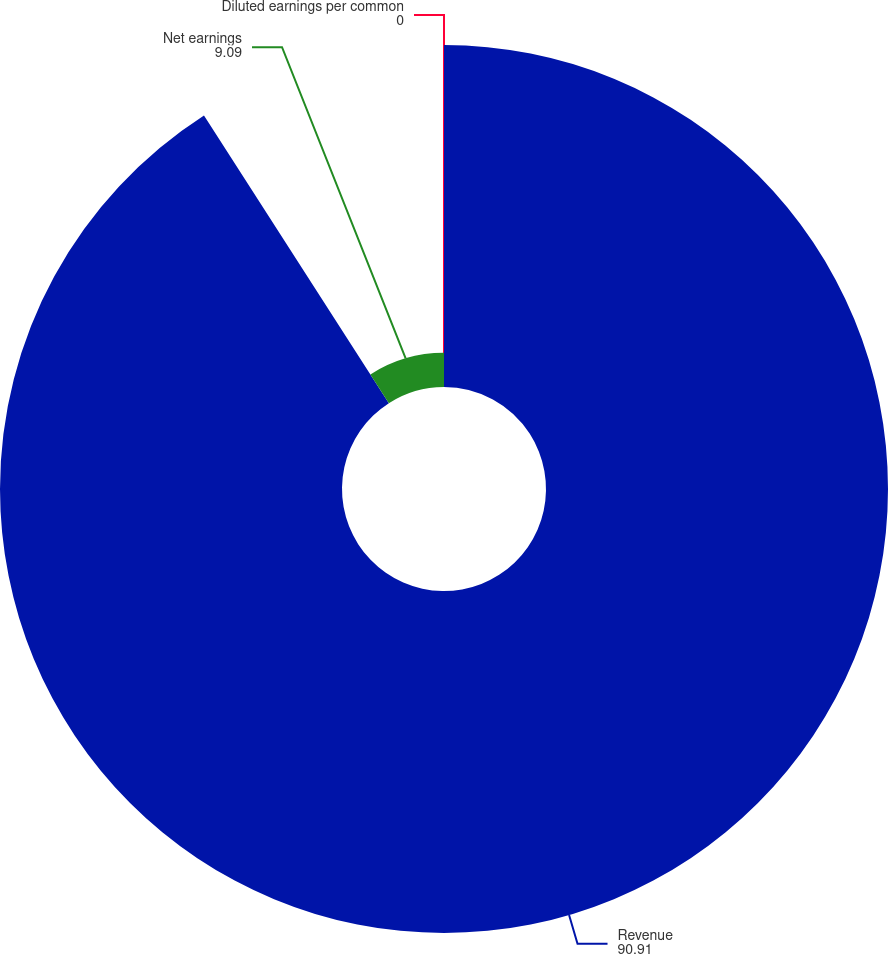<chart> <loc_0><loc_0><loc_500><loc_500><pie_chart><fcel>Revenue<fcel>Net earnings<fcel>Diluted earnings per common<nl><fcel>90.91%<fcel>9.09%<fcel>0.0%<nl></chart> 